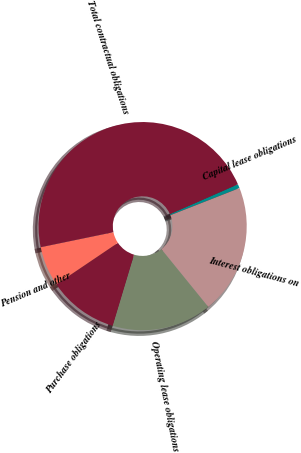Convert chart to OTSL. <chart><loc_0><loc_0><loc_500><loc_500><pie_chart><fcel>Capital lease obligations<fcel>Interest obligations on<fcel>Operating lease obligations<fcel>Purchase obligations<fcel>Pension and other<fcel>Total contractual obligations<nl><fcel>0.63%<fcel>20.1%<fcel>15.5%<fcel>10.9%<fcel>6.21%<fcel>46.66%<nl></chart> 